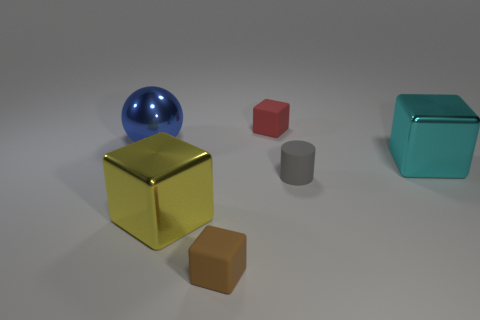Do the big thing in front of the gray thing and the tiny gray rubber object have the same shape?
Keep it short and to the point. No. Is the number of tiny brown matte blocks to the left of the blue ball greater than the number of brown matte cubes that are to the left of the small brown object?
Ensure brevity in your answer.  No. How many big blue objects have the same material as the tiny brown block?
Make the answer very short. 0. Is the size of the cyan block the same as the brown block?
Your answer should be compact. No. What color is the tiny rubber cylinder?
Ensure brevity in your answer.  Gray. What number of objects are either gray matte objects or metal balls?
Give a very brief answer. 2. Are there any other big yellow things of the same shape as the yellow metal object?
Give a very brief answer. No. Does the big shiny cube that is on the left side of the small gray cylinder have the same color as the cylinder?
Ensure brevity in your answer.  No. The matte object right of the small block that is on the right side of the tiny brown matte thing is what shape?
Provide a succinct answer. Cylinder. Are there any gray metallic objects that have the same size as the brown matte block?
Your answer should be very brief. No. 